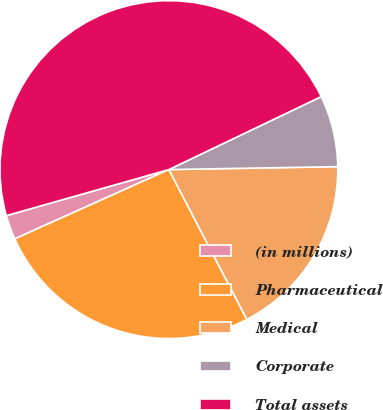Convert chart. <chart><loc_0><loc_0><loc_500><loc_500><pie_chart><fcel>(in millions)<fcel>Pharmaceutical<fcel>Medical<fcel>Corporate<fcel>Total assets<nl><fcel>2.33%<fcel>25.91%<fcel>17.64%<fcel>6.83%<fcel>47.29%<nl></chart> 